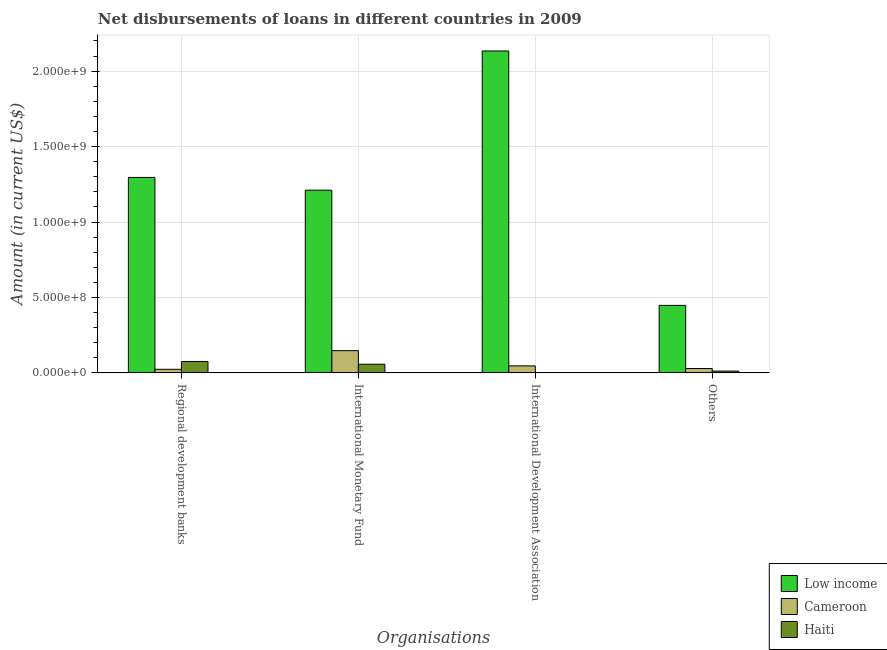Are the number of bars on each tick of the X-axis equal?
Offer a terse response. No. How many bars are there on the 1st tick from the right?
Give a very brief answer. 3. What is the label of the 4th group of bars from the left?
Your answer should be compact. Others. What is the amount of loan disimbursed by other organisations in Cameroon?
Your answer should be very brief. 2.88e+07. Across all countries, what is the maximum amount of loan disimbursed by international monetary fund?
Offer a very short reply. 1.21e+09. In which country was the amount of loan disimbursed by regional development banks maximum?
Make the answer very short. Low income. What is the total amount of loan disimbursed by other organisations in the graph?
Make the answer very short. 4.88e+08. What is the difference between the amount of loan disimbursed by other organisations in Haiti and that in Low income?
Provide a succinct answer. -4.36e+08. What is the difference between the amount of loan disimbursed by regional development banks in Low income and the amount of loan disimbursed by international development association in Haiti?
Offer a terse response. 1.30e+09. What is the average amount of loan disimbursed by regional development banks per country?
Offer a very short reply. 4.65e+08. What is the difference between the amount of loan disimbursed by international development association and amount of loan disimbursed by regional development banks in Cameroon?
Offer a very short reply. 2.27e+07. What is the ratio of the amount of loan disimbursed by international monetary fund in Cameroon to that in Haiti?
Ensure brevity in your answer.  2.57. Is the amount of loan disimbursed by international monetary fund in Haiti less than that in Low income?
Your response must be concise. Yes. Is the difference between the amount of loan disimbursed by regional development banks in Cameroon and Haiti greater than the difference between the amount of loan disimbursed by other organisations in Cameroon and Haiti?
Provide a succinct answer. No. What is the difference between the highest and the second highest amount of loan disimbursed by international monetary fund?
Your answer should be compact. 1.06e+09. What is the difference between the highest and the lowest amount of loan disimbursed by international development association?
Ensure brevity in your answer.  2.13e+09. In how many countries, is the amount of loan disimbursed by other organisations greater than the average amount of loan disimbursed by other organisations taken over all countries?
Offer a terse response. 1. Is it the case that in every country, the sum of the amount of loan disimbursed by international monetary fund and amount of loan disimbursed by other organisations is greater than the sum of amount of loan disimbursed by regional development banks and amount of loan disimbursed by international development association?
Your answer should be very brief. Yes. Is it the case that in every country, the sum of the amount of loan disimbursed by regional development banks and amount of loan disimbursed by international monetary fund is greater than the amount of loan disimbursed by international development association?
Your answer should be compact. Yes. How many bars are there?
Make the answer very short. 11. How many countries are there in the graph?
Provide a short and direct response. 3. What is the difference between two consecutive major ticks on the Y-axis?
Provide a short and direct response. 5.00e+08. Does the graph contain any zero values?
Offer a very short reply. Yes. How many legend labels are there?
Your answer should be very brief. 3. What is the title of the graph?
Give a very brief answer. Net disbursements of loans in different countries in 2009. Does "Monaco" appear as one of the legend labels in the graph?
Provide a succinct answer. No. What is the label or title of the X-axis?
Your answer should be very brief. Organisations. What is the Amount (in current US$) of Low income in Regional development banks?
Provide a short and direct response. 1.30e+09. What is the Amount (in current US$) of Cameroon in Regional development banks?
Your response must be concise. 2.36e+07. What is the Amount (in current US$) of Haiti in Regional development banks?
Offer a very short reply. 7.56e+07. What is the Amount (in current US$) in Low income in International Monetary Fund?
Give a very brief answer. 1.21e+09. What is the Amount (in current US$) of Cameroon in International Monetary Fund?
Offer a terse response. 1.47e+08. What is the Amount (in current US$) in Haiti in International Monetary Fund?
Your answer should be very brief. 5.74e+07. What is the Amount (in current US$) of Low income in International Development Association?
Offer a very short reply. 2.13e+09. What is the Amount (in current US$) of Cameroon in International Development Association?
Your response must be concise. 4.63e+07. What is the Amount (in current US$) of Low income in Others?
Provide a short and direct response. 4.47e+08. What is the Amount (in current US$) of Cameroon in Others?
Provide a short and direct response. 2.88e+07. What is the Amount (in current US$) of Haiti in Others?
Offer a very short reply. 1.18e+07. Across all Organisations, what is the maximum Amount (in current US$) of Low income?
Provide a short and direct response. 2.13e+09. Across all Organisations, what is the maximum Amount (in current US$) in Cameroon?
Ensure brevity in your answer.  1.47e+08. Across all Organisations, what is the maximum Amount (in current US$) of Haiti?
Your answer should be very brief. 7.56e+07. Across all Organisations, what is the minimum Amount (in current US$) of Low income?
Keep it short and to the point. 4.47e+08. Across all Organisations, what is the minimum Amount (in current US$) in Cameroon?
Provide a succinct answer. 2.36e+07. What is the total Amount (in current US$) in Low income in the graph?
Offer a very short reply. 5.09e+09. What is the total Amount (in current US$) of Cameroon in the graph?
Your answer should be compact. 2.46e+08. What is the total Amount (in current US$) of Haiti in the graph?
Provide a succinct answer. 1.45e+08. What is the difference between the Amount (in current US$) in Low income in Regional development banks and that in International Monetary Fund?
Your response must be concise. 8.45e+07. What is the difference between the Amount (in current US$) of Cameroon in Regional development banks and that in International Monetary Fund?
Give a very brief answer. -1.24e+08. What is the difference between the Amount (in current US$) of Haiti in Regional development banks and that in International Monetary Fund?
Your response must be concise. 1.82e+07. What is the difference between the Amount (in current US$) in Low income in Regional development banks and that in International Development Association?
Offer a very short reply. -8.38e+08. What is the difference between the Amount (in current US$) of Cameroon in Regional development banks and that in International Development Association?
Give a very brief answer. -2.27e+07. What is the difference between the Amount (in current US$) of Low income in Regional development banks and that in Others?
Give a very brief answer. 8.48e+08. What is the difference between the Amount (in current US$) in Cameroon in Regional development banks and that in Others?
Offer a very short reply. -5.22e+06. What is the difference between the Amount (in current US$) of Haiti in Regional development banks and that in Others?
Offer a very short reply. 6.38e+07. What is the difference between the Amount (in current US$) in Low income in International Monetary Fund and that in International Development Association?
Your response must be concise. -9.23e+08. What is the difference between the Amount (in current US$) of Cameroon in International Monetary Fund and that in International Development Association?
Give a very brief answer. 1.01e+08. What is the difference between the Amount (in current US$) of Low income in International Monetary Fund and that in Others?
Keep it short and to the point. 7.64e+08. What is the difference between the Amount (in current US$) in Cameroon in International Monetary Fund and that in Others?
Your answer should be very brief. 1.19e+08. What is the difference between the Amount (in current US$) in Haiti in International Monetary Fund and that in Others?
Provide a succinct answer. 4.56e+07. What is the difference between the Amount (in current US$) of Low income in International Development Association and that in Others?
Your answer should be very brief. 1.69e+09. What is the difference between the Amount (in current US$) of Cameroon in International Development Association and that in Others?
Your answer should be compact. 1.74e+07. What is the difference between the Amount (in current US$) of Low income in Regional development banks and the Amount (in current US$) of Cameroon in International Monetary Fund?
Ensure brevity in your answer.  1.15e+09. What is the difference between the Amount (in current US$) in Low income in Regional development banks and the Amount (in current US$) in Haiti in International Monetary Fund?
Your answer should be compact. 1.24e+09. What is the difference between the Amount (in current US$) of Cameroon in Regional development banks and the Amount (in current US$) of Haiti in International Monetary Fund?
Your answer should be very brief. -3.38e+07. What is the difference between the Amount (in current US$) in Low income in Regional development banks and the Amount (in current US$) in Cameroon in International Development Association?
Ensure brevity in your answer.  1.25e+09. What is the difference between the Amount (in current US$) of Low income in Regional development banks and the Amount (in current US$) of Cameroon in Others?
Provide a succinct answer. 1.27e+09. What is the difference between the Amount (in current US$) in Low income in Regional development banks and the Amount (in current US$) in Haiti in Others?
Give a very brief answer. 1.28e+09. What is the difference between the Amount (in current US$) of Cameroon in Regional development banks and the Amount (in current US$) of Haiti in Others?
Your answer should be compact. 1.18e+07. What is the difference between the Amount (in current US$) of Low income in International Monetary Fund and the Amount (in current US$) of Cameroon in International Development Association?
Provide a succinct answer. 1.16e+09. What is the difference between the Amount (in current US$) of Low income in International Monetary Fund and the Amount (in current US$) of Cameroon in Others?
Give a very brief answer. 1.18e+09. What is the difference between the Amount (in current US$) in Low income in International Monetary Fund and the Amount (in current US$) in Haiti in Others?
Your response must be concise. 1.20e+09. What is the difference between the Amount (in current US$) in Cameroon in International Monetary Fund and the Amount (in current US$) in Haiti in Others?
Your answer should be very brief. 1.36e+08. What is the difference between the Amount (in current US$) of Low income in International Development Association and the Amount (in current US$) of Cameroon in Others?
Offer a very short reply. 2.11e+09. What is the difference between the Amount (in current US$) in Low income in International Development Association and the Amount (in current US$) in Haiti in Others?
Give a very brief answer. 2.12e+09. What is the difference between the Amount (in current US$) in Cameroon in International Development Association and the Amount (in current US$) in Haiti in Others?
Give a very brief answer. 3.45e+07. What is the average Amount (in current US$) in Low income per Organisations?
Ensure brevity in your answer.  1.27e+09. What is the average Amount (in current US$) of Cameroon per Organisations?
Provide a short and direct response. 6.15e+07. What is the average Amount (in current US$) of Haiti per Organisations?
Provide a short and direct response. 3.62e+07. What is the difference between the Amount (in current US$) in Low income and Amount (in current US$) in Cameroon in Regional development banks?
Offer a very short reply. 1.27e+09. What is the difference between the Amount (in current US$) in Low income and Amount (in current US$) in Haiti in Regional development banks?
Give a very brief answer. 1.22e+09. What is the difference between the Amount (in current US$) of Cameroon and Amount (in current US$) of Haiti in Regional development banks?
Your answer should be very brief. -5.20e+07. What is the difference between the Amount (in current US$) in Low income and Amount (in current US$) in Cameroon in International Monetary Fund?
Your answer should be compact. 1.06e+09. What is the difference between the Amount (in current US$) in Low income and Amount (in current US$) in Haiti in International Monetary Fund?
Provide a short and direct response. 1.15e+09. What is the difference between the Amount (in current US$) in Cameroon and Amount (in current US$) in Haiti in International Monetary Fund?
Provide a succinct answer. 8.99e+07. What is the difference between the Amount (in current US$) in Low income and Amount (in current US$) in Cameroon in International Development Association?
Your answer should be very brief. 2.09e+09. What is the difference between the Amount (in current US$) in Low income and Amount (in current US$) in Cameroon in Others?
Give a very brief answer. 4.19e+08. What is the difference between the Amount (in current US$) in Low income and Amount (in current US$) in Haiti in Others?
Give a very brief answer. 4.36e+08. What is the difference between the Amount (in current US$) of Cameroon and Amount (in current US$) of Haiti in Others?
Your answer should be compact. 1.70e+07. What is the ratio of the Amount (in current US$) in Low income in Regional development banks to that in International Monetary Fund?
Make the answer very short. 1.07. What is the ratio of the Amount (in current US$) in Cameroon in Regional development banks to that in International Monetary Fund?
Provide a short and direct response. 0.16. What is the ratio of the Amount (in current US$) of Haiti in Regional development banks to that in International Monetary Fund?
Provide a short and direct response. 1.32. What is the ratio of the Amount (in current US$) in Low income in Regional development banks to that in International Development Association?
Keep it short and to the point. 0.61. What is the ratio of the Amount (in current US$) in Cameroon in Regional development banks to that in International Development Association?
Provide a short and direct response. 0.51. What is the ratio of the Amount (in current US$) of Low income in Regional development banks to that in Others?
Provide a short and direct response. 2.9. What is the ratio of the Amount (in current US$) in Cameroon in Regional development banks to that in Others?
Keep it short and to the point. 0.82. What is the ratio of the Amount (in current US$) of Haiti in Regional development banks to that in Others?
Your answer should be very brief. 6.4. What is the ratio of the Amount (in current US$) of Low income in International Monetary Fund to that in International Development Association?
Your response must be concise. 0.57. What is the ratio of the Amount (in current US$) of Cameroon in International Monetary Fund to that in International Development Association?
Your response must be concise. 3.18. What is the ratio of the Amount (in current US$) in Low income in International Monetary Fund to that in Others?
Your answer should be very brief. 2.71. What is the ratio of the Amount (in current US$) of Cameroon in International Monetary Fund to that in Others?
Give a very brief answer. 5.11. What is the ratio of the Amount (in current US$) of Haiti in International Monetary Fund to that in Others?
Your answer should be very brief. 4.86. What is the ratio of the Amount (in current US$) of Low income in International Development Association to that in Others?
Your answer should be very brief. 4.77. What is the ratio of the Amount (in current US$) in Cameroon in International Development Association to that in Others?
Make the answer very short. 1.61. What is the difference between the highest and the second highest Amount (in current US$) in Low income?
Your answer should be very brief. 8.38e+08. What is the difference between the highest and the second highest Amount (in current US$) of Cameroon?
Give a very brief answer. 1.01e+08. What is the difference between the highest and the second highest Amount (in current US$) of Haiti?
Keep it short and to the point. 1.82e+07. What is the difference between the highest and the lowest Amount (in current US$) in Low income?
Your answer should be very brief. 1.69e+09. What is the difference between the highest and the lowest Amount (in current US$) in Cameroon?
Provide a succinct answer. 1.24e+08. What is the difference between the highest and the lowest Amount (in current US$) in Haiti?
Provide a succinct answer. 7.56e+07. 